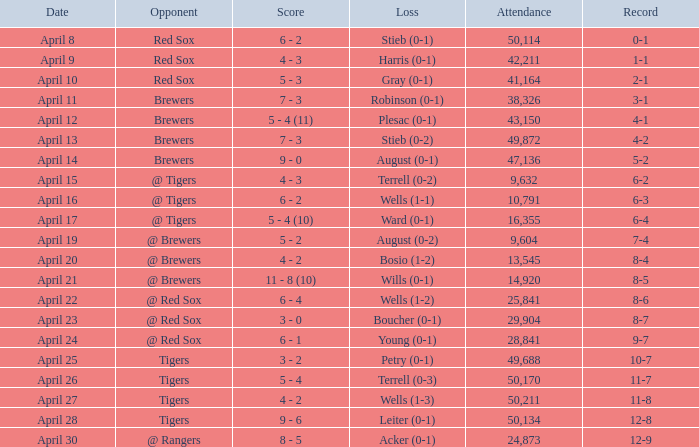Which loss has a record of 11-8 and an attendance exceeding 49,688? Wells (1-3). 